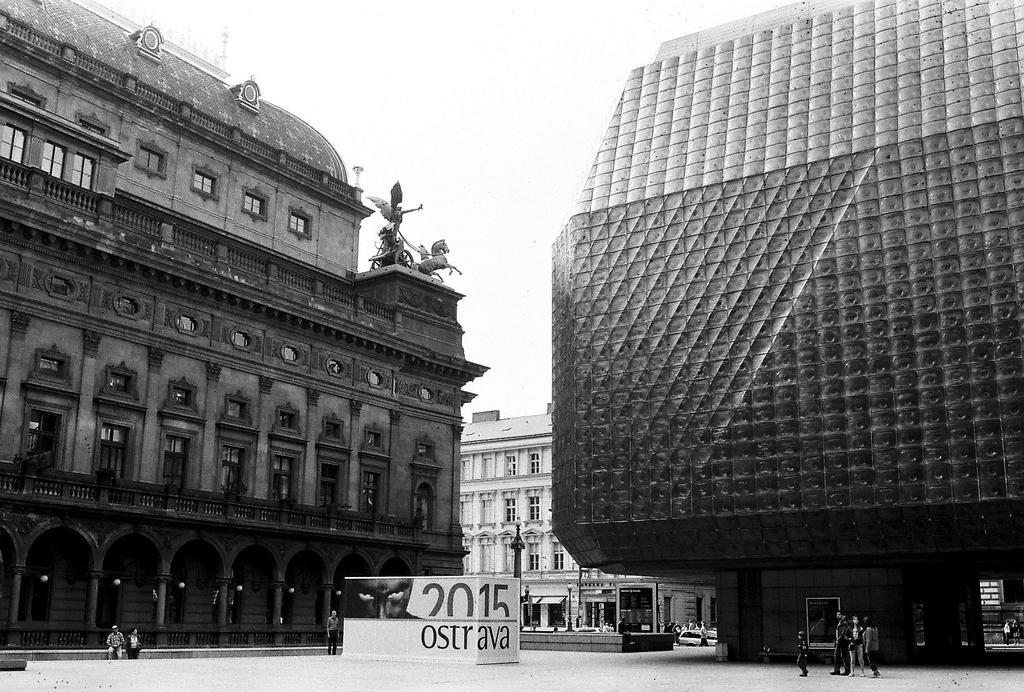Describe this image in one or two sentences. In this picture we can see different buildings in front of which people are standing on the road. 